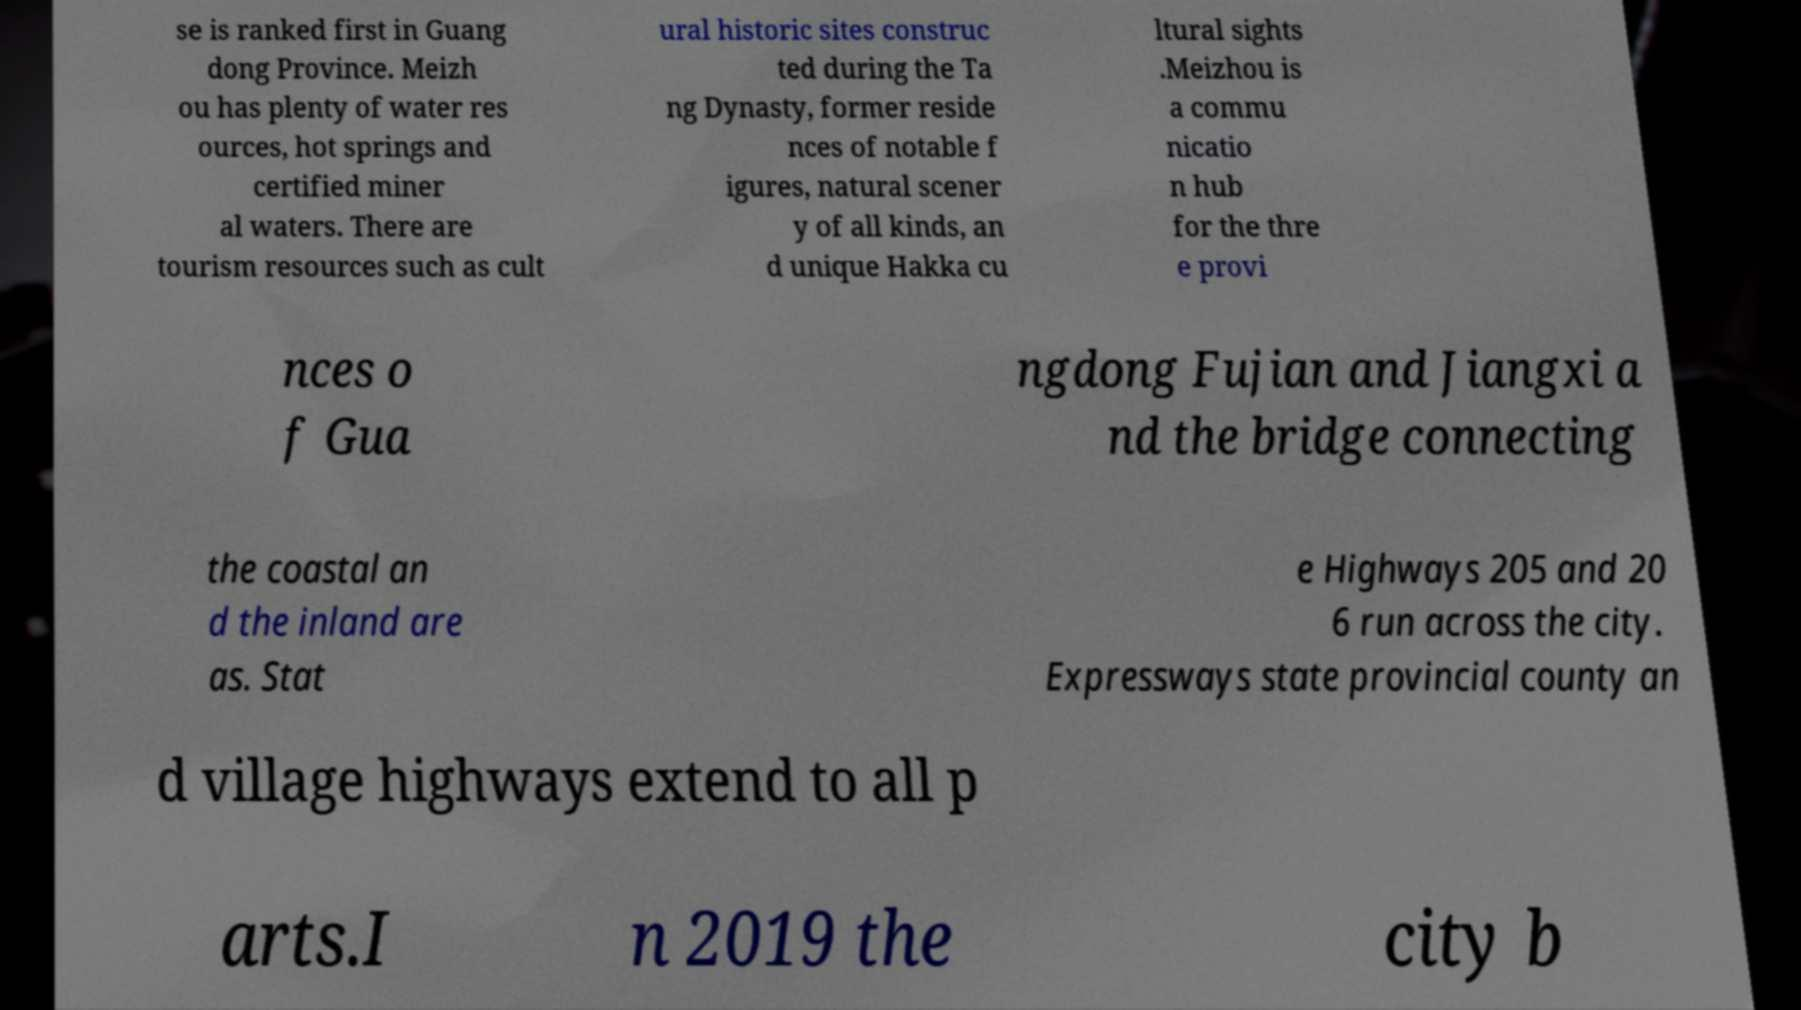Could you assist in decoding the text presented in this image and type it out clearly? se is ranked first in Guang dong Province. Meizh ou has plenty of water res ources, hot springs and certified miner al waters. There are tourism resources such as cult ural historic sites construc ted during the Ta ng Dynasty, former reside nces of notable f igures, natural scener y of all kinds, an d unique Hakka cu ltural sights .Meizhou is a commu nicatio n hub for the thre e provi nces o f Gua ngdong Fujian and Jiangxi a nd the bridge connecting the coastal an d the inland are as. Stat e Highways 205 and 20 6 run across the city. Expressways state provincial county an d village highways extend to all p arts.I n 2019 the city b 